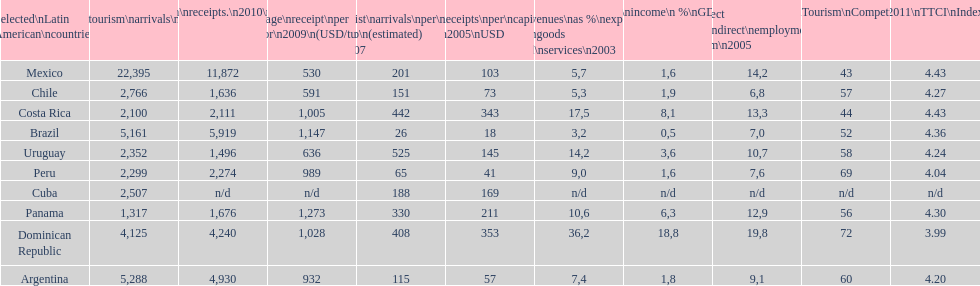Could you parse the entire table? {'header': ['Selected\\nLatin American\\ncountries', 'Internl.\\ntourism\\narrivals\\n2010\\n(x 1000)', 'Internl.\\ntourism\\nreceipts.\\n2010\\n(USD\\n(x1000)', 'Average\\nreceipt\\nper visitor\\n2009\\n(USD/turista)', 'Tourist\\narrivals\\nper\\n1000 inhab\\n(estimated) \\n2007', 'Receipts\\nper\\ncapita \\n2005\\nUSD', 'Revenues\\nas\xa0%\\nexports of\\ngoods and\\nservices\\n2003', 'Tourism\\nincome\\n\xa0%\\nGDP\\n2003', '% Direct and\\nindirect\\nemployment\\nin tourism\\n2005', 'World\\nranking\\nTourism\\nCompetitiv.\\nTTCI\\n2011', '2011\\nTTCI\\nIndex'], 'rows': [['Mexico', '22,395', '11,872', '530', '201', '103', '5,7', '1,6', '14,2', '43', '4.43'], ['Chile', '2,766', '1,636', '591', '151', '73', '5,3', '1,9', '6,8', '57', '4.27'], ['Costa Rica', '2,100', '2,111', '1,005', '442', '343', '17,5', '8,1', '13,3', '44', '4.43'], ['Brazil', '5,161', '5,919', '1,147', '26', '18', '3,2', '0,5', '7,0', '52', '4.36'], ['Uruguay', '2,352', '1,496', '636', '525', '145', '14,2', '3,6', '10,7', '58', '4.24'], ['Peru', '2,299', '2,274', '989', '65', '41', '9,0', '1,6', '7,6', '69', '4.04'], ['Cuba', '2,507', 'n/d', 'n/d', '188', '169', 'n/d', 'n/d', 'n/d', 'n/d', 'n/d'], ['Panama', '1,317', '1,676', '1,273', '330', '211', '10,6', '6,3', '12,9', '56', '4.30'], ['Dominican Republic', '4,125', '4,240', '1,028', '408', '353', '36,2', '18,8', '19,8', '72', '3.99'], ['Argentina', '5,288', '4,930', '932', '115', '57', '7,4', '1,8', '9,1', '60', '4.20']]} What country had the most receipts per capita in 2005? Dominican Republic. 